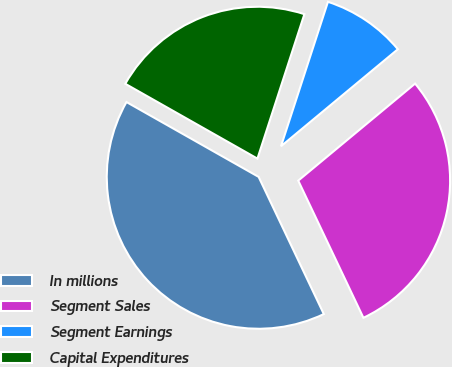Convert chart. <chart><loc_0><loc_0><loc_500><loc_500><pie_chart><fcel>In millions<fcel>Segment Sales<fcel>Segment Earnings<fcel>Capital Expenditures<nl><fcel>40.26%<fcel>28.97%<fcel>8.97%<fcel>21.8%<nl></chart> 